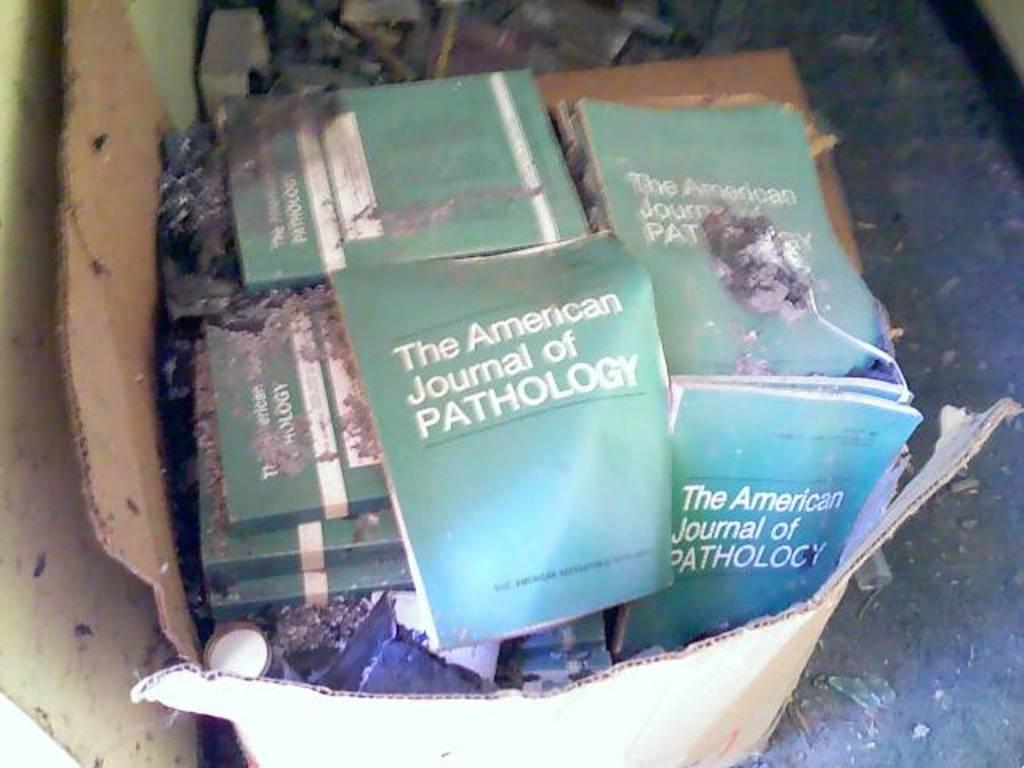Provide a one-sentence caption for the provided image. A torn cardboard box contains many copies of "The American Journal of Pathology". 